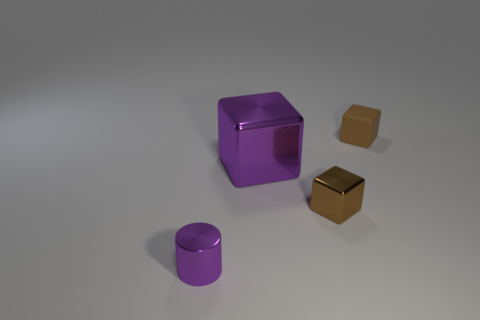Add 2 large blue rubber objects. How many objects exist? 6 Subtract all cubes. How many objects are left? 1 Subtract all tiny purple objects. Subtract all cylinders. How many objects are left? 2 Add 3 big purple metallic cubes. How many big purple metallic cubes are left? 4 Add 4 small red cylinders. How many small red cylinders exist? 4 Subtract 0 blue cylinders. How many objects are left? 4 